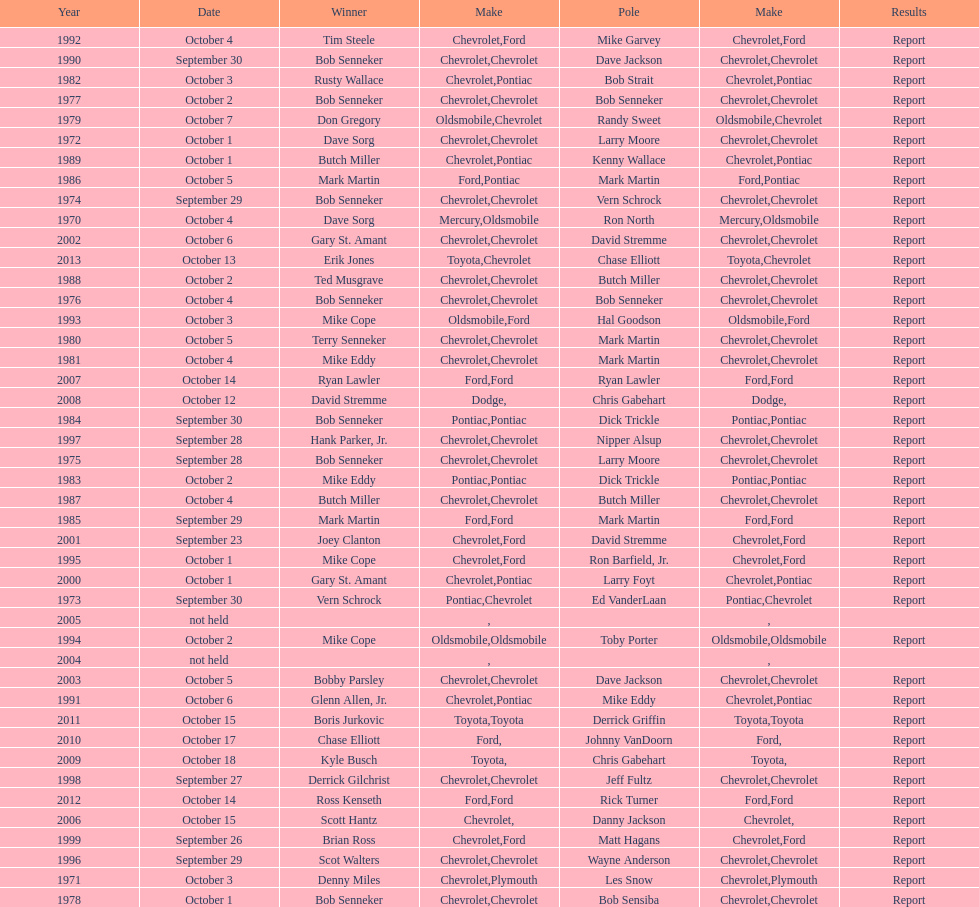How many winning oldsmobile vehicles made the list? 3. 